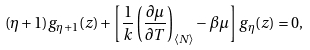Convert formula to latex. <formula><loc_0><loc_0><loc_500><loc_500>( \eta + 1 ) g _ { \eta + 1 } ( z ) + \left [ \frac { 1 } { k } \left ( \frac { \partial \mu } { \partial T } \right ) _ { \langle N \rangle } - \beta \mu \right ] g _ { \eta } ( z ) = 0 ,</formula> 